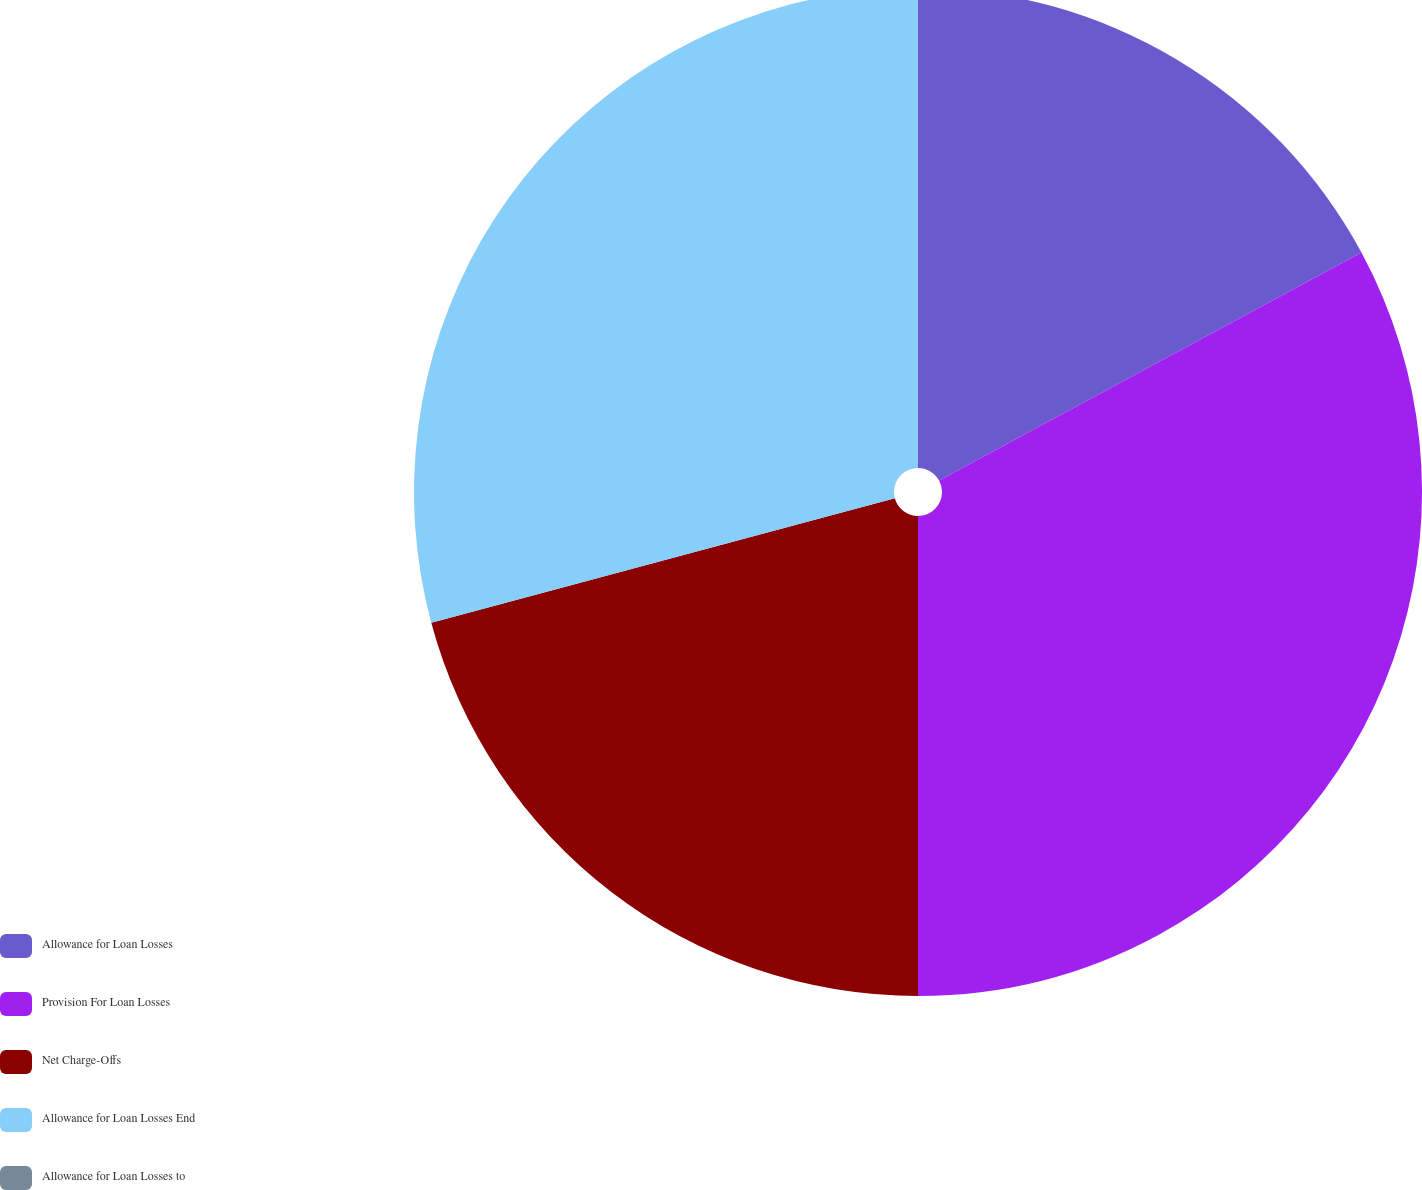Convert chart. <chart><loc_0><loc_0><loc_500><loc_500><pie_chart><fcel>Allowance for Loan Losses<fcel>Provision For Loan Losses<fcel>Net Charge-Offs<fcel>Allowance for Loan Losses End<fcel>Allowance for Loan Losses to<nl><fcel>17.12%<fcel>32.88%<fcel>20.82%<fcel>29.18%<fcel>0.0%<nl></chart> 